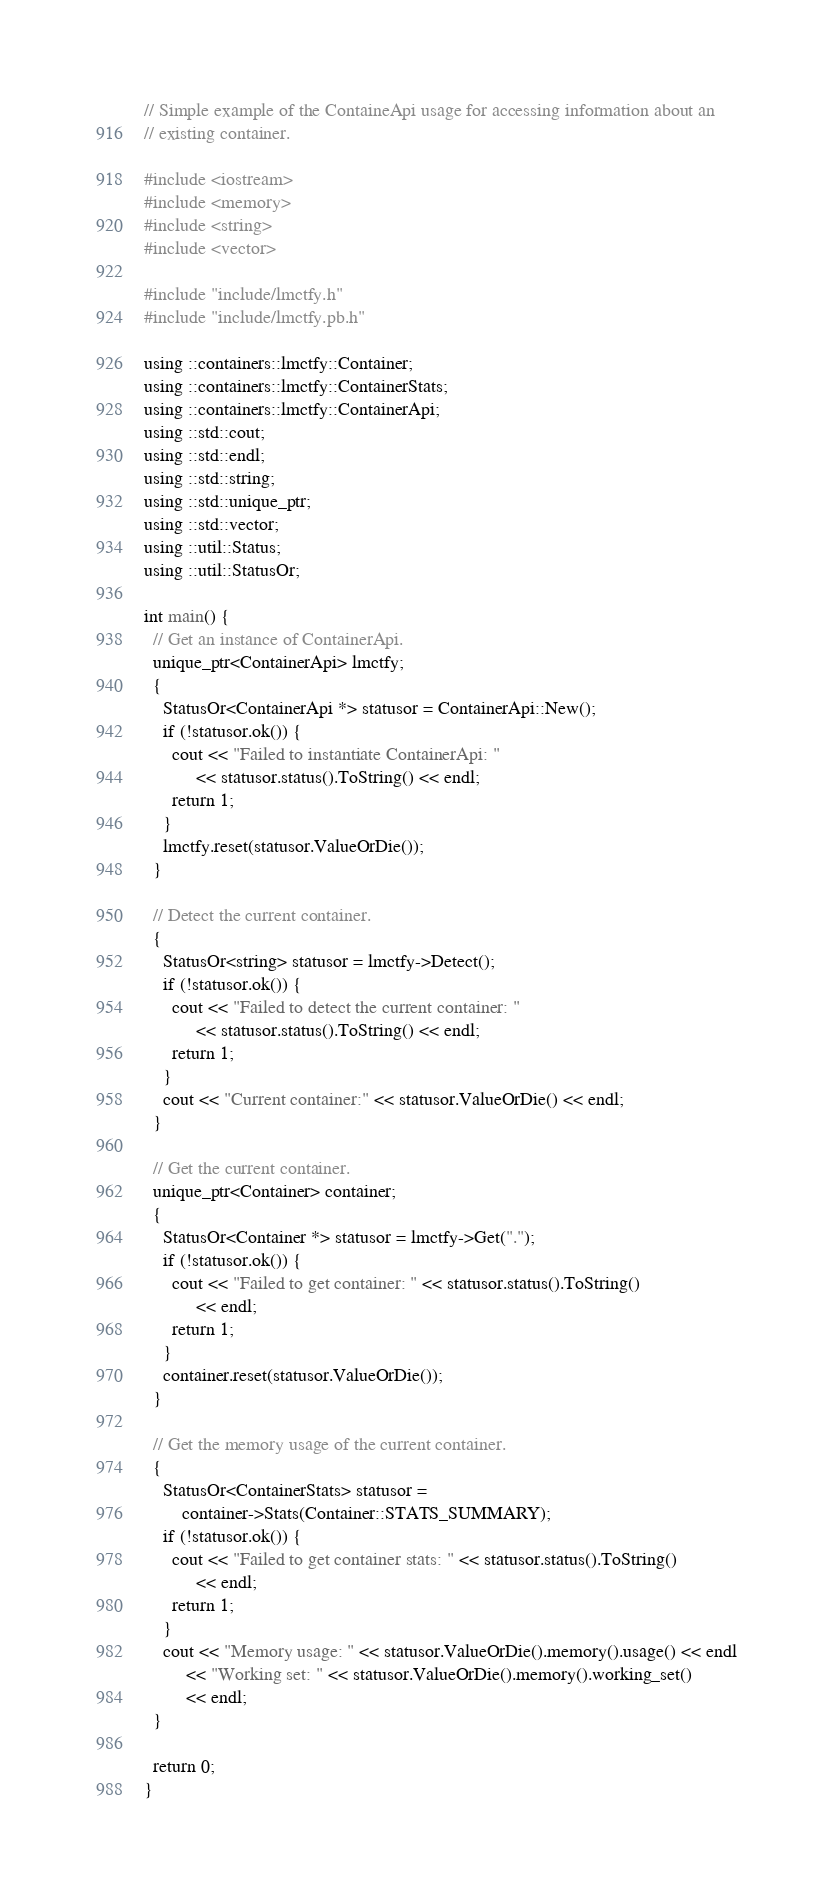<code> <loc_0><loc_0><loc_500><loc_500><_C++_>// Simple example of the ContaineApi usage for accessing information about an
// existing container.

#include <iostream>
#include <memory>
#include <string>
#include <vector>

#include "include/lmctfy.h"
#include "include/lmctfy.pb.h"

using ::containers::lmctfy::Container;
using ::containers::lmctfy::ContainerStats;
using ::containers::lmctfy::ContainerApi;
using ::std::cout;
using ::std::endl;
using ::std::string;
using ::std::unique_ptr;
using ::std::vector;
using ::util::Status;
using ::util::StatusOr;

int main() {
  // Get an instance of ContainerApi.
  unique_ptr<ContainerApi> lmctfy;
  {
    StatusOr<ContainerApi *> statusor = ContainerApi::New();
    if (!statusor.ok()) {
      cout << "Failed to instantiate ContainerApi: "
           << statusor.status().ToString() << endl;
      return 1;
    }
    lmctfy.reset(statusor.ValueOrDie());
  }

  // Detect the current container.
  {
    StatusOr<string> statusor = lmctfy->Detect();
    if (!statusor.ok()) {
      cout << "Failed to detect the current container: "
           << statusor.status().ToString() << endl;
      return 1;
    }
    cout << "Current container:" << statusor.ValueOrDie() << endl;
  }

  // Get the current container.
  unique_ptr<Container> container;
  {
    StatusOr<Container *> statusor = lmctfy->Get(".");
    if (!statusor.ok()) {
      cout << "Failed to get container: " << statusor.status().ToString()
           << endl;
      return 1;
    }
    container.reset(statusor.ValueOrDie());
  }

  // Get the memory usage of the current container.
  {
    StatusOr<ContainerStats> statusor =
        container->Stats(Container::STATS_SUMMARY);
    if (!statusor.ok()) {
      cout << "Failed to get container stats: " << statusor.status().ToString()
           << endl;
      return 1;
    }
    cout << "Memory usage: " << statusor.ValueOrDie().memory().usage() << endl
         << "Working set: " << statusor.ValueOrDie().memory().working_set()
         << endl;
  }

  return 0;
}
</code> 